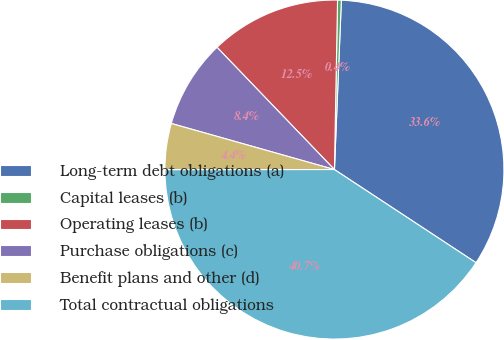<chart> <loc_0><loc_0><loc_500><loc_500><pie_chart><fcel>Long-term debt obligations (a)<fcel>Capital leases (b)<fcel>Operating leases (b)<fcel>Purchase obligations (c)<fcel>Benefit plans and other (d)<fcel>Total contractual obligations<nl><fcel>33.61%<fcel>0.36%<fcel>12.47%<fcel>8.44%<fcel>4.4%<fcel>40.72%<nl></chart> 